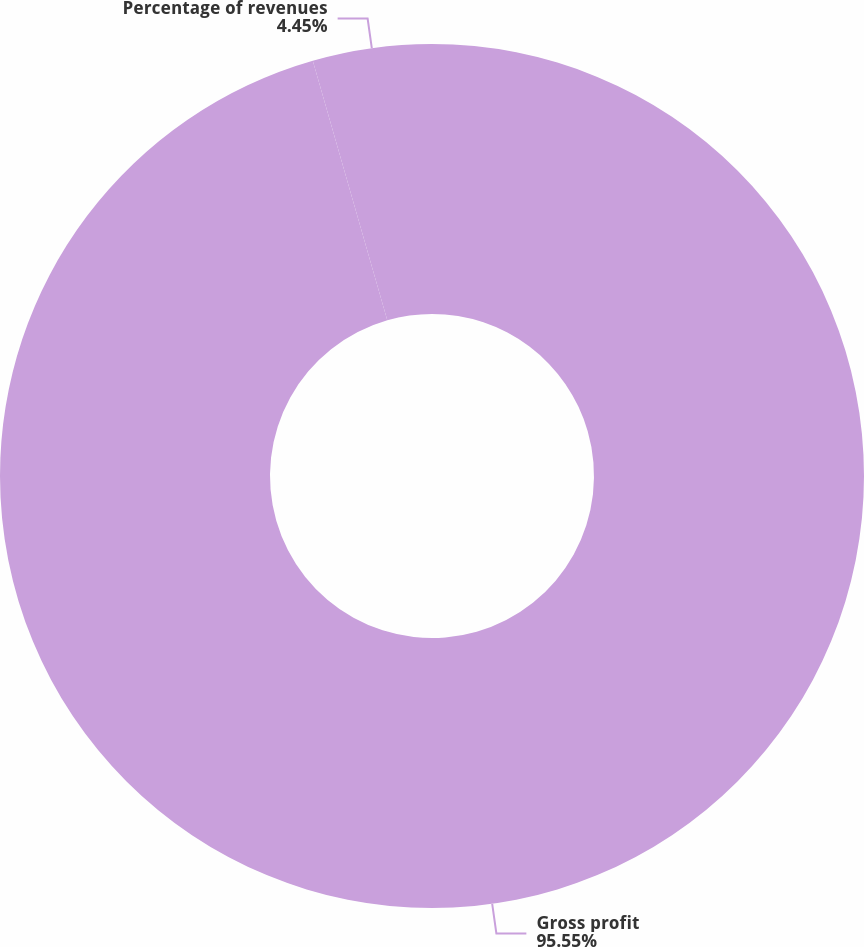Convert chart to OTSL. <chart><loc_0><loc_0><loc_500><loc_500><pie_chart><fcel>Gross profit<fcel>Percentage of revenues<nl><fcel>95.55%<fcel>4.45%<nl></chart> 